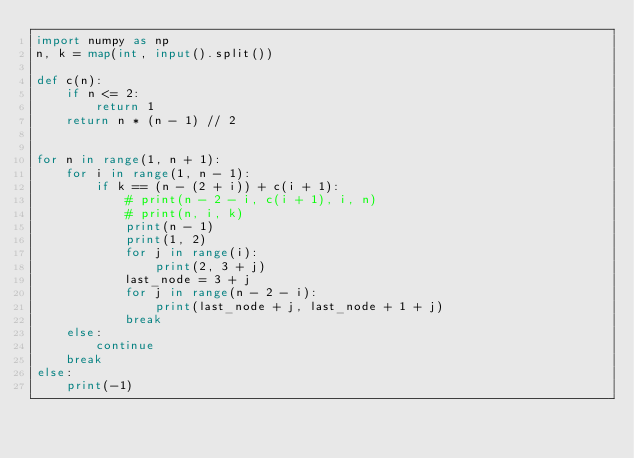Convert code to text. <code><loc_0><loc_0><loc_500><loc_500><_Python_>import numpy as np
n, k = map(int, input().split())

def c(n):
    if n <= 2:
        return 1
    return n * (n - 1) // 2


for n in range(1, n + 1):
    for i in range(1, n - 1):
        if k == (n - (2 + i)) + c(i + 1):
            # print(n - 2 - i, c(i + 1), i, n)
            # print(n, i, k)
            print(n - 1)
            print(1, 2)
            for j in range(i):
                print(2, 3 + j)
            last_node = 3 + j
            for j in range(n - 2 - i):
                print(last_node + j, last_node + 1 + j)
            break
    else:
        continue
    break
else:
    print(-1)
</code> 